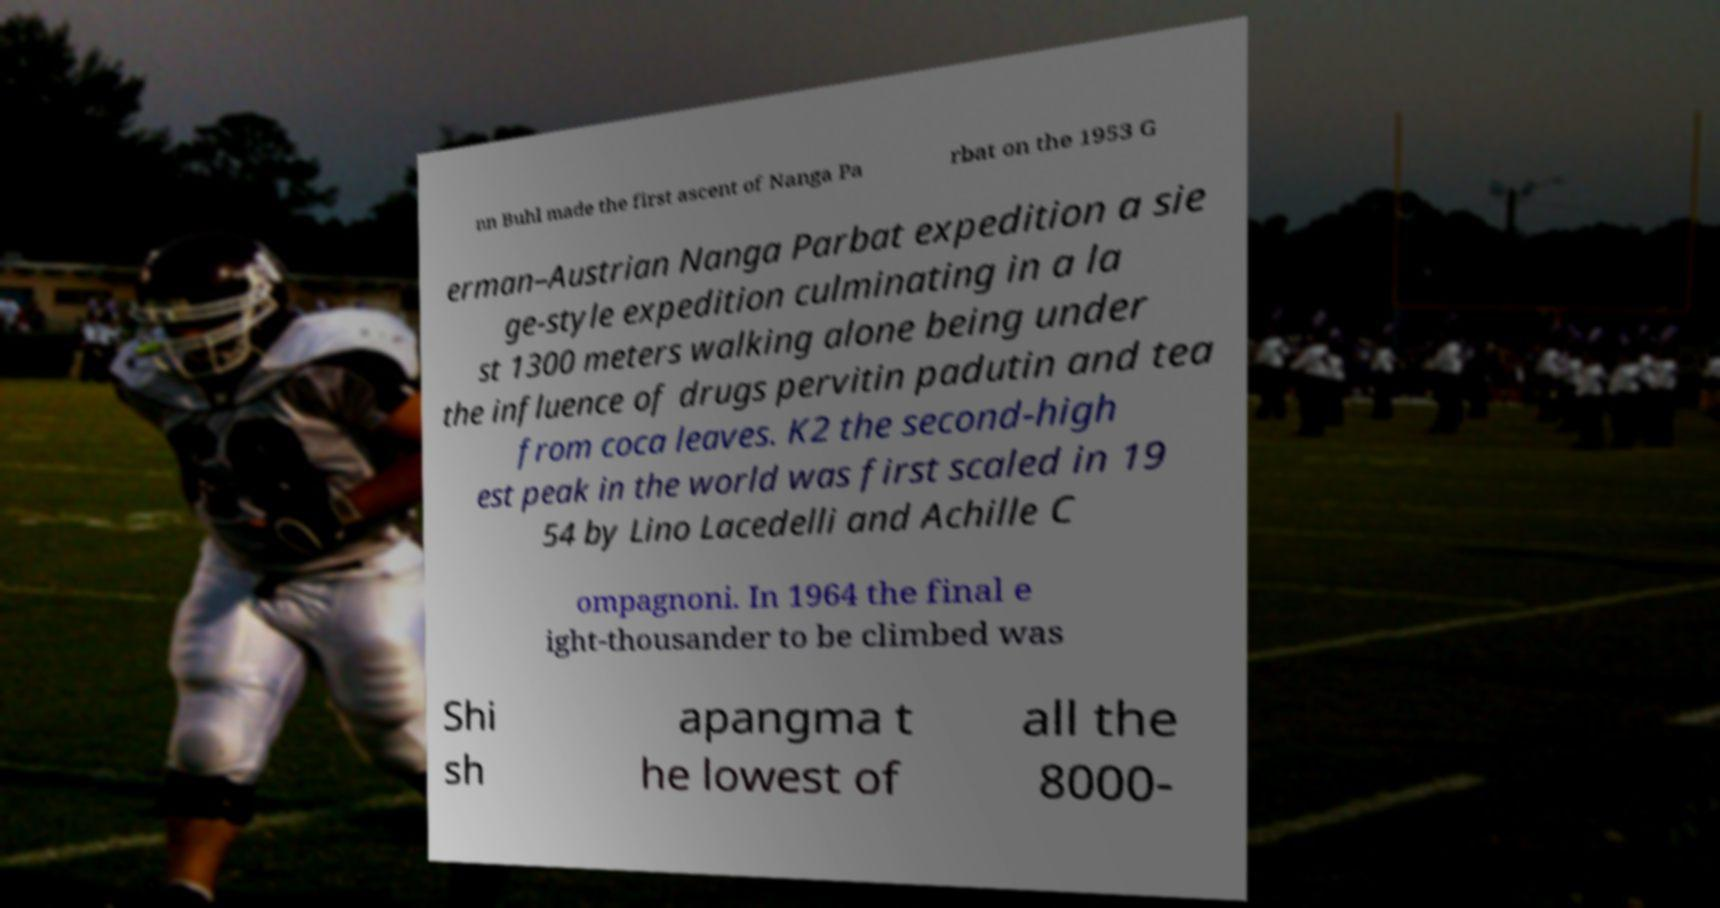Please read and relay the text visible in this image. What does it say? nn Buhl made the first ascent of Nanga Pa rbat on the 1953 G erman–Austrian Nanga Parbat expedition a sie ge-style expedition culminating in a la st 1300 meters walking alone being under the influence of drugs pervitin padutin and tea from coca leaves. K2 the second-high est peak in the world was first scaled in 19 54 by Lino Lacedelli and Achille C ompagnoni. In 1964 the final e ight-thousander to be climbed was Shi sh apangma t he lowest of all the 8000- 